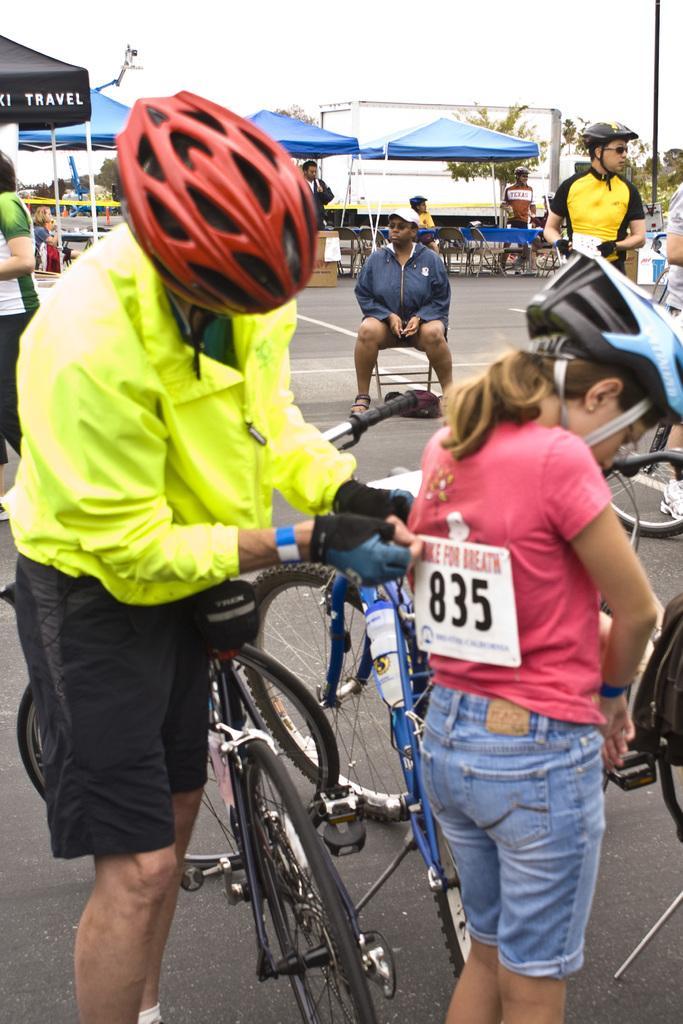How would you summarize this image in a sentence or two? In this image there is a person in the middle who is wearing the green color jacket and red color helmet is sticking the badge to the girl who is in front of him. There are cycles in between them. In the background there are few people standing on the road. In the middle there is a person sitting in the chair. In the background there are tents under which there are few people. On the left side there is another tent. 